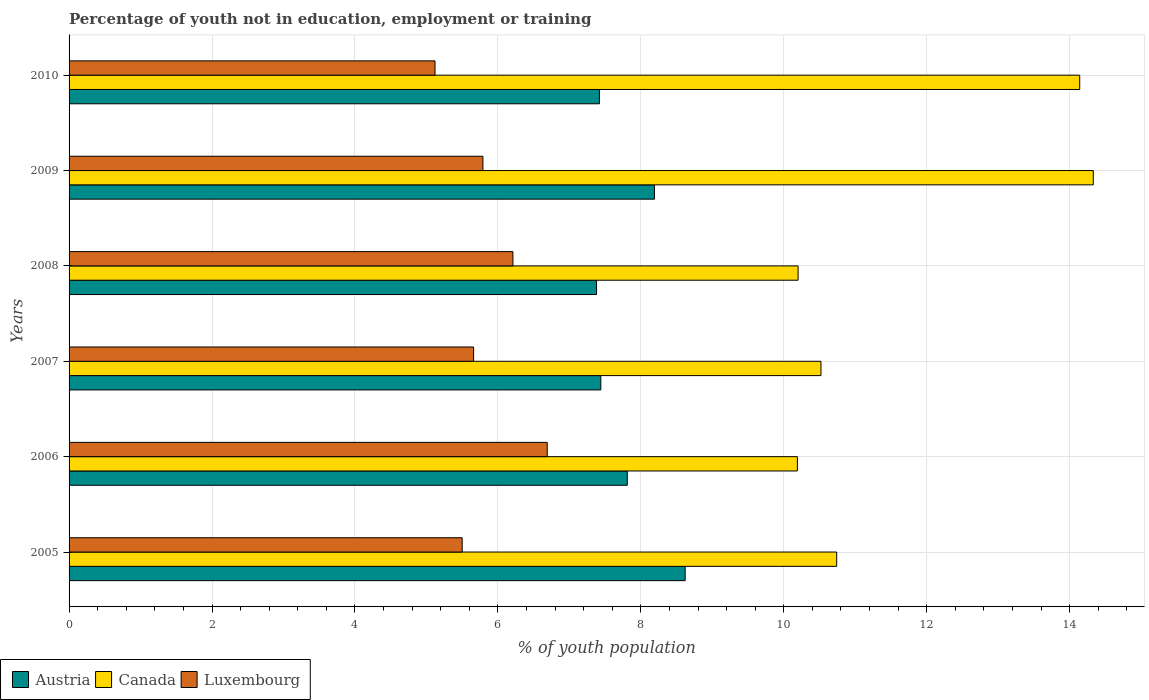How many groups of bars are there?
Keep it short and to the point. 6. What is the percentage of unemployed youth population in in Austria in 2010?
Offer a terse response. 7.42. Across all years, what is the maximum percentage of unemployed youth population in in Canada?
Offer a terse response. 14.33. Across all years, what is the minimum percentage of unemployed youth population in in Austria?
Your answer should be very brief. 7.38. In which year was the percentage of unemployed youth population in in Luxembourg maximum?
Provide a short and direct response. 2006. In which year was the percentage of unemployed youth population in in Canada minimum?
Your answer should be very brief. 2006. What is the total percentage of unemployed youth population in in Luxembourg in the graph?
Offer a very short reply. 34.97. What is the difference between the percentage of unemployed youth population in in Canada in 2005 and that in 2007?
Provide a succinct answer. 0.22. What is the difference between the percentage of unemployed youth population in in Luxembourg in 2006 and the percentage of unemployed youth population in in Austria in 2009?
Your answer should be compact. -1.5. What is the average percentage of unemployed youth population in in Austria per year?
Ensure brevity in your answer.  7.81. In the year 2009, what is the difference between the percentage of unemployed youth population in in Luxembourg and percentage of unemployed youth population in in Austria?
Offer a terse response. -2.4. What is the ratio of the percentage of unemployed youth population in in Canada in 2008 to that in 2010?
Make the answer very short. 0.72. Is the percentage of unemployed youth population in in Luxembourg in 2005 less than that in 2008?
Offer a very short reply. Yes. Is the difference between the percentage of unemployed youth population in in Luxembourg in 2005 and 2006 greater than the difference between the percentage of unemployed youth population in in Austria in 2005 and 2006?
Make the answer very short. No. What is the difference between the highest and the second highest percentage of unemployed youth population in in Austria?
Your answer should be compact. 0.43. What is the difference between the highest and the lowest percentage of unemployed youth population in in Luxembourg?
Your response must be concise. 1.57. In how many years, is the percentage of unemployed youth population in in Austria greater than the average percentage of unemployed youth population in in Austria taken over all years?
Give a very brief answer. 2. Is the sum of the percentage of unemployed youth population in in Canada in 2007 and 2008 greater than the maximum percentage of unemployed youth population in in Luxembourg across all years?
Provide a short and direct response. Yes. What does the 1st bar from the top in 2008 represents?
Provide a short and direct response. Luxembourg. Is it the case that in every year, the sum of the percentage of unemployed youth population in in Canada and percentage of unemployed youth population in in Austria is greater than the percentage of unemployed youth population in in Luxembourg?
Offer a terse response. Yes. What is the difference between two consecutive major ticks on the X-axis?
Your answer should be compact. 2. Are the values on the major ticks of X-axis written in scientific E-notation?
Give a very brief answer. No. Does the graph contain any zero values?
Provide a short and direct response. No. Does the graph contain grids?
Make the answer very short. Yes. Where does the legend appear in the graph?
Your answer should be compact. Bottom left. What is the title of the graph?
Keep it short and to the point. Percentage of youth not in education, employment or training. Does "Madagascar" appear as one of the legend labels in the graph?
Your response must be concise. No. What is the label or title of the X-axis?
Keep it short and to the point. % of youth population. What is the % of youth population in Austria in 2005?
Give a very brief answer. 8.62. What is the % of youth population of Canada in 2005?
Your answer should be very brief. 10.74. What is the % of youth population of Austria in 2006?
Give a very brief answer. 7.81. What is the % of youth population in Canada in 2006?
Your response must be concise. 10.19. What is the % of youth population of Luxembourg in 2006?
Your answer should be very brief. 6.69. What is the % of youth population in Austria in 2007?
Keep it short and to the point. 7.44. What is the % of youth population in Canada in 2007?
Give a very brief answer. 10.52. What is the % of youth population in Luxembourg in 2007?
Make the answer very short. 5.66. What is the % of youth population in Austria in 2008?
Your answer should be compact. 7.38. What is the % of youth population in Canada in 2008?
Your answer should be compact. 10.2. What is the % of youth population in Luxembourg in 2008?
Make the answer very short. 6.21. What is the % of youth population in Austria in 2009?
Ensure brevity in your answer.  8.19. What is the % of youth population in Canada in 2009?
Provide a succinct answer. 14.33. What is the % of youth population of Luxembourg in 2009?
Provide a succinct answer. 5.79. What is the % of youth population of Austria in 2010?
Your answer should be compact. 7.42. What is the % of youth population in Canada in 2010?
Ensure brevity in your answer.  14.14. What is the % of youth population in Luxembourg in 2010?
Make the answer very short. 5.12. Across all years, what is the maximum % of youth population of Austria?
Your answer should be compact. 8.62. Across all years, what is the maximum % of youth population of Canada?
Offer a very short reply. 14.33. Across all years, what is the maximum % of youth population of Luxembourg?
Your response must be concise. 6.69. Across all years, what is the minimum % of youth population in Austria?
Offer a terse response. 7.38. Across all years, what is the minimum % of youth population of Canada?
Your response must be concise. 10.19. Across all years, what is the minimum % of youth population in Luxembourg?
Offer a very short reply. 5.12. What is the total % of youth population in Austria in the graph?
Provide a short and direct response. 46.86. What is the total % of youth population in Canada in the graph?
Offer a very short reply. 70.12. What is the total % of youth population in Luxembourg in the graph?
Your answer should be compact. 34.97. What is the difference between the % of youth population in Austria in 2005 and that in 2006?
Offer a terse response. 0.81. What is the difference between the % of youth population in Canada in 2005 and that in 2006?
Ensure brevity in your answer.  0.55. What is the difference between the % of youth population in Luxembourg in 2005 and that in 2006?
Make the answer very short. -1.19. What is the difference between the % of youth population of Austria in 2005 and that in 2007?
Give a very brief answer. 1.18. What is the difference between the % of youth population of Canada in 2005 and that in 2007?
Keep it short and to the point. 0.22. What is the difference between the % of youth population in Luxembourg in 2005 and that in 2007?
Keep it short and to the point. -0.16. What is the difference between the % of youth population in Austria in 2005 and that in 2008?
Offer a terse response. 1.24. What is the difference between the % of youth population of Canada in 2005 and that in 2008?
Give a very brief answer. 0.54. What is the difference between the % of youth population in Luxembourg in 2005 and that in 2008?
Provide a short and direct response. -0.71. What is the difference between the % of youth population in Austria in 2005 and that in 2009?
Your answer should be very brief. 0.43. What is the difference between the % of youth population in Canada in 2005 and that in 2009?
Ensure brevity in your answer.  -3.59. What is the difference between the % of youth population of Luxembourg in 2005 and that in 2009?
Your answer should be compact. -0.29. What is the difference between the % of youth population in Canada in 2005 and that in 2010?
Offer a terse response. -3.4. What is the difference between the % of youth population of Luxembourg in 2005 and that in 2010?
Ensure brevity in your answer.  0.38. What is the difference between the % of youth population of Austria in 2006 and that in 2007?
Give a very brief answer. 0.37. What is the difference between the % of youth population of Canada in 2006 and that in 2007?
Your answer should be compact. -0.33. What is the difference between the % of youth population of Luxembourg in 2006 and that in 2007?
Offer a very short reply. 1.03. What is the difference between the % of youth population of Austria in 2006 and that in 2008?
Provide a short and direct response. 0.43. What is the difference between the % of youth population in Canada in 2006 and that in 2008?
Ensure brevity in your answer.  -0.01. What is the difference between the % of youth population in Luxembourg in 2006 and that in 2008?
Make the answer very short. 0.48. What is the difference between the % of youth population in Austria in 2006 and that in 2009?
Ensure brevity in your answer.  -0.38. What is the difference between the % of youth population of Canada in 2006 and that in 2009?
Make the answer very short. -4.14. What is the difference between the % of youth population in Austria in 2006 and that in 2010?
Provide a short and direct response. 0.39. What is the difference between the % of youth population in Canada in 2006 and that in 2010?
Give a very brief answer. -3.95. What is the difference between the % of youth population of Luxembourg in 2006 and that in 2010?
Offer a terse response. 1.57. What is the difference between the % of youth population in Canada in 2007 and that in 2008?
Provide a succinct answer. 0.32. What is the difference between the % of youth population of Luxembourg in 2007 and that in 2008?
Your response must be concise. -0.55. What is the difference between the % of youth population in Austria in 2007 and that in 2009?
Make the answer very short. -0.75. What is the difference between the % of youth population of Canada in 2007 and that in 2009?
Your answer should be compact. -3.81. What is the difference between the % of youth population in Luxembourg in 2007 and that in 2009?
Ensure brevity in your answer.  -0.13. What is the difference between the % of youth population in Austria in 2007 and that in 2010?
Make the answer very short. 0.02. What is the difference between the % of youth population of Canada in 2007 and that in 2010?
Give a very brief answer. -3.62. What is the difference between the % of youth population in Luxembourg in 2007 and that in 2010?
Provide a short and direct response. 0.54. What is the difference between the % of youth population of Austria in 2008 and that in 2009?
Provide a short and direct response. -0.81. What is the difference between the % of youth population of Canada in 2008 and that in 2009?
Your answer should be compact. -4.13. What is the difference between the % of youth population of Luxembourg in 2008 and that in 2009?
Give a very brief answer. 0.42. What is the difference between the % of youth population in Austria in 2008 and that in 2010?
Provide a succinct answer. -0.04. What is the difference between the % of youth population in Canada in 2008 and that in 2010?
Your response must be concise. -3.94. What is the difference between the % of youth population in Luxembourg in 2008 and that in 2010?
Keep it short and to the point. 1.09. What is the difference between the % of youth population in Austria in 2009 and that in 2010?
Keep it short and to the point. 0.77. What is the difference between the % of youth population of Canada in 2009 and that in 2010?
Offer a terse response. 0.19. What is the difference between the % of youth population of Luxembourg in 2009 and that in 2010?
Your answer should be compact. 0.67. What is the difference between the % of youth population in Austria in 2005 and the % of youth population in Canada in 2006?
Make the answer very short. -1.57. What is the difference between the % of youth population of Austria in 2005 and the % of youth population of Luxembourg in 2006?
Your answer should be compact. 1.93. What is the difference between the % of youth population in Canada in 2005 and the % of youth population in Luxembourg in 2006?
Your response must be concise. 4.05. What is the difference between the % of youth population in Austria in 2005 and the % of youth population in Canada in 2007?
Make the answer very short. -1.9. What is the difference between the % of youth population in Austria in 2005 and the % of youth population in Luxembourg in 2007?
Ensure brevity in your answer.  2.96. What is the difference between the % of youth population in Canada in 2005 and the % of youth population in Luxembourg in 2007?
Make the answer very short. 5.08. What is the difference between the % of youth population of Austria in 2005 and the % of youth population of Canada in 2008?
Your answer should be compact. -1.58. What is the difference between the % of youth population of Austria in 2005 and the % of youth population of Luxembourg in 2008?
Ensure brevity in your answer.  2.41. What is the difference between the % of youth population of Canada in 2005 and the % of youth population of Luxembourg in 2008?
Keep it short and to the point. 4.53. What is the difference between the % of youth population in Austria in 2005 and the % of youth population in Canada in 2009?
Your answer should be very brief. -5.71. What is the difference between the % of youth population of Austria in 2005 and the % of youth population of Luxembourg in 2009?
Keep it short and to the point. 2.83. What is the difference between the % of youth population of Canada in 2005 and the % of youth population of Luxembourg in 2009?
Keep it short and to the point. 4.95. What is the difference between the % of youth population of Austria in 2005 and the % of youth population of Canada in 2010?
Ensure brevity in your answer.  -5.52. What is the difference between the % of youth population of Canada in 2005 and the % of youth population of Luxembourg in 2010?
Give a very brief answer. 5.62. What is the difference between the % of youth population in Austria in 2006 and the % of youth population in Canada in 2007?
Give a very brief answer. -2.71. What is the difference between the % of youth population in Austria in 2006 and the % of youth population in Luxembourg in 2007?
Ensure brevity in your answer.  2.15. What is the difference between the % of youth population of Canada in 2006 and the % of youth population of Luxembourg in 2007?
Provide a succinct answer. 4.53. What is the difference between the % of youth population of Austria in 2006 and the % of youth population of Canada in 2008?
Your response must be concise. -2.39. What is the difference between the % of youth population of Canada in 2006 and the % of youth population of Luxembourg in 2008?
Ensure brevity in your answer.  3.98. What is the difference between the % of youth population of Austria in 2006 and the % of youth population of Canada in 2009?
Your response must be concise. -6.52. What is the difference between the % of youth population in Austria in 2006 and the % of youth population in Luxembourg in 2009?
Your answer should be very brief. 2.02. What is the difference between the % of youth population of Canada in 2006 and the % of youth population of Luxembourg in 2009?
Make the answer very short. 4.4. What is the difference between the % of youth population in Austria in 2006 and the % of youth population in Canada in 2010?
Ensure brevity in your answer.  -6.33. What is the difference between the % of youth population of Austria in 2006 and the % of youth population of Luxembourg in 2010?
Give a very brief answer. 2.69. What is the difference between the % of youth population in Canada in 2006 and the % of youth population in Luxembourg in 2010?
Your response must be concise. 5.07. What is the difference between the % of youth population of Austria in 2007 and the % of youth population of Canada in 2008?
Your response must be concise. -2.76. What is the difference between the % of youth population of Austria in 2007 and the % of youth population of Luxembourg in 2008?
Your answer should be very brief. 1.23. What is the difference between the % of youth population of Canada in 2007 and the % of youth population of Luxembourg in 2008?
Offer a terse response. 4.31. What is the difference between the % of youth population in Austria in 2007 and the % of youth population in Canada in 2009?
Offer a terse response. -6.89. What is the difference between the % of youth population in Austria in 2007 and the % of youth population in Luxembourg in 2009?
Make the answer very short. 1.65. What is the difference between the % of youth population of Canada in 2007 and the % of youth population of Luxembourg in 2009?
Make the answer very short. 4.73. What is the difference between the % of youth population in Austria in 2007 and the % of youth population in Luxembourg in 2010?
Offer a terse response. 2.32. What is the difference between the % of youth population in Canada in 2007 and the % of youth population in Luxembourg in 2010?
Make the answer very short. 5.4. What is the difference between the % of youth population of Austria in 2008 and the % of youth population of Canada in 2009?
Provide a short and direct response. -6.95. What is the difference between the % of youth population of Austria in 2008 and the % of youth population of Luxembourg in 2009?
Offer a very short reply. 1.59. What is the difference between the % of youth population in Canada in 2008 and the % of youth population in Luxembourg in 2009?
Your answer should be very brief. 4.41. What is the difference between the % of youth population in Austria in 2008 and the % of youth population in Canada in 2010?
Ensure brevity in your answer.  -6.76. What is the difference between the % of youth population in Austria in 2008 and the % of youth population in Luxembourg in 2010?
Your answer should be very brief. 2.26. What is the difference between the % of youth population of Canada in 2008 and the % of youth population of Luxembourg in 2010?
Make the answer very short. 5.08. What is the difference between the % of youth population in Austria in 2009 and the % of youth population in Canada in 2010?
Your answer should be compact. -5.95. What is the difference between the % of youth population in Austria in 2009 and the % of youth population in Luxembourg in 2010?
Keep it short and to the point. 3.07. What is the difference between the % of youth population of Canada in 2009 and the % of youth population of Luxembourg in 2010?
Keep it short and to the point. 9.21. What is the average % of youth population in Austria per year?
Your answer should be very brief. 7.81. What is the average % of youth population in Canada per year?
Make the answer very short. 11.69. What is the average % of youth population in Luxembourg per year?
Provide a short and direct response. 5.83. In the year 2005, what is the difference between the % of youth population of Austria and % of youth population of Canada?
Provide a succinct answer. -2.12. In the year 2005, what is the difference between the % of youth population of Austria and % of youth population of Luxembourg?
Provide a succinct answer. 3.12. In the year 2005, what is the difference between the % of youth population of Canada and % of youth population of Luxembourg?
Your response must be concise. 5.24. In the year 2006, what is the difference between the % of youth population in Austria and % of youth population in Canada?
Provide a succinct answer. -2.38. In the year 2006, what is the difference between the % of youth population in Austria and % of youth population in Luxembourg?
Provide a short and direct response. 1.12. In the year 2007, what is the difference between the % of youth population in Austria and % of youth population in Canada?
Provide a short and direct response. -3.08. In the year 2007, what is the difference between the % of youth population in Austria and % of youth population in Luxembourg?
Offer a terse response. 1.78. In the year 2007, what is the difference between the % of youth population of Canada and % of youth population of Luxembourg?
Your response must be concise. 4.86. In the year 2008, what is the difference between the % of youth population in Austria and % of youth population in Canada?
Offer a terse response. -2.82. In the year 2008, what is the difference between the % of youth population of Austria and % of youth population of Luxembourg?
Ensure brevity in your answer.  1.17. In the year 2008, what is the difference between the % of youth population in Canada and % of youth population in Luxembourg?
Ensure brevity in your answer.  3.99. In the year 2009, what is the difference between the % of youth population of Austria and % of youth population of Canada?
Keep it short and to the point. -6.14. In the year 2009, what is the difference between the % of youth population of Canada and % of youth population of Luxembourg?
Ensure brevity in your answer.  8.54. In the year 2010, what is the difference between the % of youth population in Austria and % of youth population in Canada?
Your answer should be very brief. -6.72. In the year 2010, what is the difference between the % of youth population in Austria and % of youth population in Luxembourg?
Offer a very short reply. 2.3. In the year 2010, what is the difference between the % of youth population of Canada and % of youth population of Luxembourg?
Ensure brevity in your answer.  9.02. What is the ratio of the % of youth population of Austria in 2005 to that in 2006?
Ensure brevity in your answer.  1.1. What is the ratio of the % of youth population in Canada in 2005 to that in 2006?
Provide a short and direct response. 1.05. What is the ratio of the % of youth population of Luxembourg in 2005 to that in 2006?
Ensure brevity in your answer.  0.82. What is the ratio of the % of youth population of Austria in 2005 to that in 2007?
Keep it short and to the point. 1.16. What is the ratio of the % of youth population of Canada in 2005 to that in 2007?
Provide a short and direct response. 1.02. What is the ratio of the % of youth population of Luxembourg in 2005 to that in 2007?
Provide a succinct answer. 0.97. What is the ratio of the % of youth population in Austria in 2005 to that in 2008?
Your answer should be very brief. 1.17. What is the ratio of the % of youth population of Canada in 2005 to that in 2008?
Provide a short and direct response. 1.05. What is the ratio of the % of youth population of Luxembourg in 2005 to that in 2008?
Ensure brevity in your answer.  0.89. What is the ratio of the % of youth population in Austria in 2005 to that in 2009?
Provide a succinct answer. 1.05. What is the ratio of the % of youth population of Canada in 2005 to that in 2009?
Your answer should be compact. 0.75. What is the ratio of the % of youth population in Luxembourg in 2005 to that in 2009?
Your answer should be very brief. 0.95. What is the ratio of the % of youth population of Austria in 2005 to that in 2010?
Keep it short and to the point. 1.16. What is the ratio of the % of youth population in Canada in 2005 to that in 2010?
Your response must be concise. 0.76. What is the ratio of the % of youth population of Luxembourg in 2005 to that in 2010?
Give a very brief answer. 1.07. What is the ratio of the % of youth population in Austria in 2006 to that in 2007?
Provide a succinct answer. 1.05. What is the ratio of the % of youth population in Canada in 2006 to that in 2007?
Provide a succinct answer. 0.97. What is the ratio of the % of youth population in Luxembourg in 2006 to that in 2007?
Offer a terse response. 1.18. What is the ratio of the % of youth population of Austria in 2006 to that in 2008?
Make the answer very short. 1.06. What is the ratio of the % of youth population of Luxembourg in 2006 to that in 2008?
Offer a terse response. 1.08. What is the ratio of the % of youth population in Austria in 2006 to that in 2009?
Make the answer very short. 0.95. What is the ratio of the % of youth population of Canada in 2006 to that in 2009?
Offer a terse response. 0.71. What is the ratio of the % of youth population of Luxembourg in 2006 to that in 2009?
Keep it short and to the point. 1.16. What is the ratio of the % of youth population in Austria in 2006 to that in 2010?
Make the answer very short. 1.05. What is the ratio of the % of youth population of Canada in 2006 to that in 2010?
Your answer should be compact. 0.72. What is the ratio of the % of youth population in Luxembourg in 2006 to that in 2010?
Offer a very short reply. 1.31. What is the ratio of the % of youth population of Austria in 2007 to that in 2008?
Your answer should be compact. 1.01. What is the ratio of the % of youth population in Canada in 2007 to that in 2008?
Your answer should be very brief. 1.03. What is the ratio of the % of youth population in Luxembourg in 2007 to that in 2008?
Give a very brief answer. 0.91. What is the ratio of the % of youth population in Austria in 2007 to that in 2009?
Your answer should be very brief. 0.91. What is the ratio of the % of youth population in Canada in 2007 to that in 2009?
Offer a terse response. 0.73. What is the ratio of the % of youth population in Luxembourg in 2007 to that in 2009?
Ensure brevity in your answer.  0.98. What is the ratio of the % of youth population of Canada in 2007 to that in 2010?
Offer a terse response. 0.74. What is the ratio of the % of youth population of Luxembourg in 2007 to that in 2010?
Provide a succinct answer. 1.11. What is the ratio of the % of youth population of Austria in 2008 to that in 2009?
Provide a short and direct response. 0.9. What is the ratio of the % of youth population in Canada in 2008 to that in 2009?
Offer a terse response. 0.71. What is the ratio of the % of youth population in Luxembourg in 2008 to that in 2009?
Provide a short and direct response. 1.07. What is the ratio of the % of youth population in Austria in 2008 to that in 2010?
Offer a terse response. 0.99. What is the ratio of the % of youth population of Canada in 2008 to that in 2010?
Make the answer very short. 0.72. What is the ratio of the % of youth population in Luxembourg in 2008 to that in 2010?
Your answer should be very brief. 1.21. What is the ratio of the % of youth population in Austria in 2009 to that in 2010?
Your answer should be very brief. 1.1. What is the ratio of the % of youth population of Canada in 2009 to that in 2010?
Provide a short and direct response. 1.01. What is the ratio of the % of youth population in Luxembourg in 2009 to that in 2010?
Provide a short and direct response. 1.13. What is the difference between the highest and the second highest % of youth population of Austria?
Ensure brevity in your answer.  0.43. What is the difference between the highest and the second highest % of youth population of Canada?
Give a very brief answer. 0.19. What is the difference between the highest and the second highest % of youth population of Luxembourg?
Provide a short and direct response. 0.48. What is the difference between the highest and the lowest % of youth population in Austria?
Your answer should be very brief. 1.24. What is the difference between the highest and the lowest % of youth population of Canada?
Ensure brevity in your answer.  4.14. What is the difference between the highest and the lowest % of youth population in Luxembourg?
Keep it short and to the point. 1.57. 